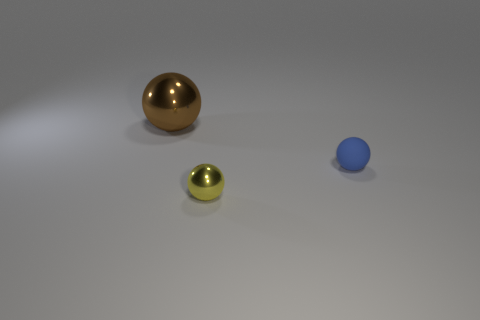Are there any other things that have the same material as the small blue sphere?
Offer a very short reply. No. Is there any other thing that has the same size as the brown thing?
Offer a terse response. No. What number of objects are metal spheres that are behind the tiny yellow metal object or spheres in front of the blue rubber object?
Keep it short and to the point. 2. There is a brown shiny object; is it the same size as the metallic sphere that is in front of the large metal ball?
Ensure brevity in your answer.  No. Are the small object in front of the small matte sphere and the big brown sphere that is behind the small matte object made of the same material?
Ensure brevity in your answer.  Yes. Are there an equal number of metal balls that are in front of the big thing and brown things that are on the left side of the blue matte thing?
Ensure brevity in your answer.  Yes. How many tiny matte balls are the same color as the big shiny sphere?
Your answer should be compact. 0. How many metallic objects are either cyan blocks or large brown things?
Provide a short and direct response. 1. There is a shiny object in front of the big brown shiny ball; is its shape the same as the thing that is behind the tiny blue matte object?
Your answer should be very brief. Yes. There is a large shiny sphere; what number of big objects are on the left side of it?
Provide a short and direct response. 0. 